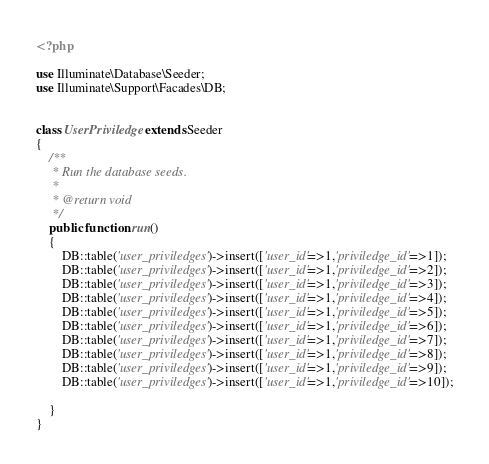Convert code to text. <code><loc_0><loc_0><loc_500><loc_500><_PHP_><?php

use Illuminate\Database\Seeder;
use Illuminate\Support\Facades\DB;


class UserPriviledge extends Seeder
{
    /**
     * Run the database seeds.
     *
     * @return void
     */
    public function run()
    {
        DB::table('user_priviledges')->insert(['user_id'=>1,'priviledge_id'=>1]);
        DB::table('user_priviledges')->insert(['user_id'=>1,'priviledge_id'=>2]);
        DB::table('user_priviledges')->insert(['user_id'=>1,'priviledge_id'=>3]);
        DB::table('user_priviledges')->insert(['user_id'=>1,'priviledge_id'=>4]);
        DB::table('user_priviledges')->insert(['user_id'=>1,'priviledge_id'=>5]);
        DB::table('user_priviledges')->insert(['user_id'=>1,'priviledge_id'=>6]);
        DB::table('user_priviledges')->insert(['user_id'=>1,'priviledge_id'=>7]);
        DB::table('user_priviledges')->insert(['user_id'=>1,'priviledge_id'=>8]);
        DB::table('user_priviledges')->insert(['user_id'=>1,'priviledge_id'=>9]);
        DB::table('user_priviledges')->insert(['user_id'=>1,'priviledge_id'=>10]);

    }
}
</code> 